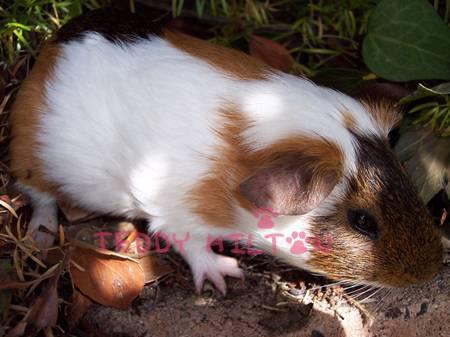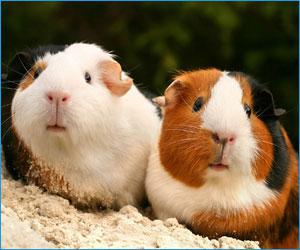The first image is the image on the left, the second image is the image on the right. Given the left and right images, does the statement "No image contains more than two guinea pigs, and one image features two multi-color guinea pigs posed side-by-side and facing straight ahead." hold true? Answer yes or no. Yes. The first image is the image on the left, the second image is the image on the right. Analyze the images presented: Is the assertion "One images shows only one guinea pig and the other shows at least two." valid? Answer yes or no. Yes. 